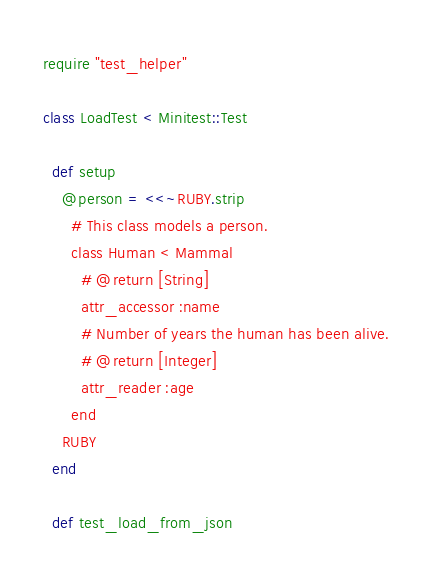Convert code to text. <code><loc_0><loc_0><loc_500><loc_500><_Ruby_>require "test_helper"

class LoadTest < Minitest::Test

  def setup
    @person = <<~RUBY.strip
      # This class models a person.
      class Human < Mammal
        # @return [String]
        attr_accessor :name
        # Number of years the human has been alive.
        # @return [Integer]
        attr_reader :age
      end
    RUBY
  end

  def test_load_from_json</code> 